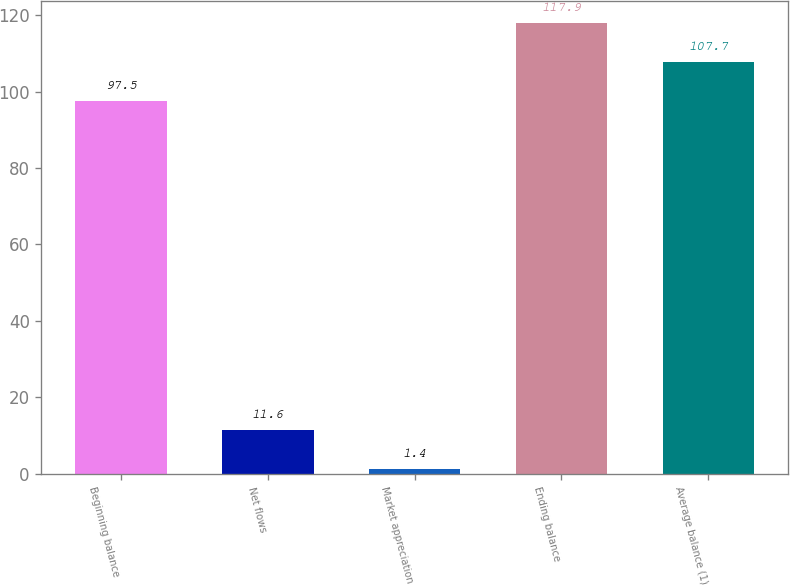<chart> <loc_0><loc_0><loc_500><loc_500><bar_chart><fcel>Beginning balance<fcel>Net flows<fcel>Market appreciation<fcel>Ending balance<fcel>Average balance (1)<nl><fcel>97.5<fcel>11.6<fcel>1.4<fcel>117.9<fcel>107.7<nl></chart> 